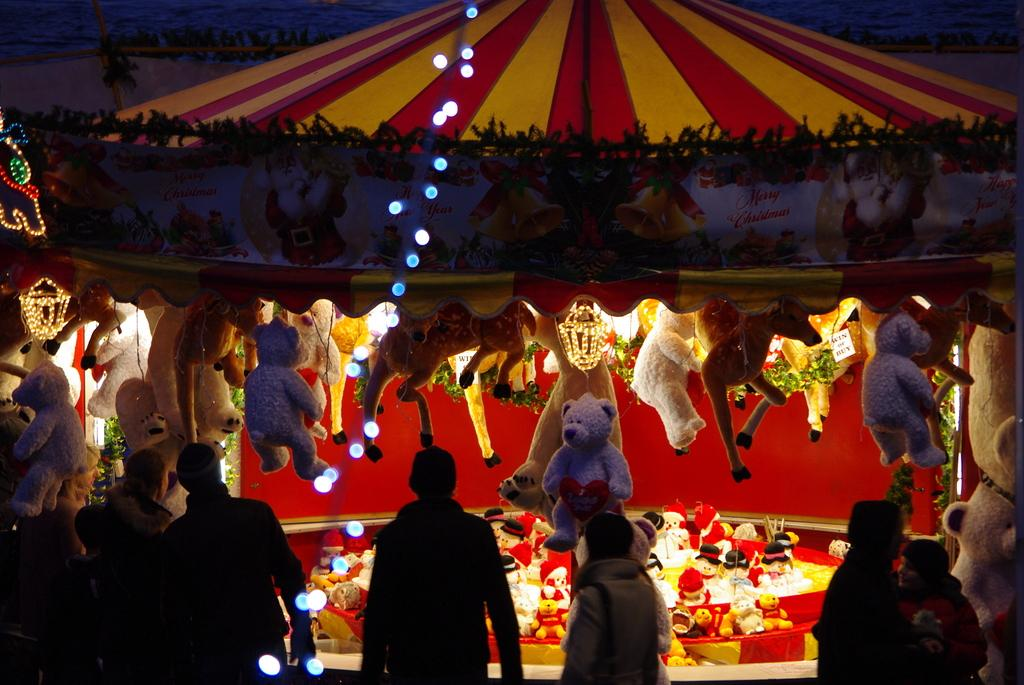Who or what can be seen in the image? There are people and dolls in the image. What structure is present in the image? There is a tent in the image. What can be used for illumination in the image? There are lights in the image. What can be seen hanging in the image? There is a banner in the image. What additional items are present in the image? There are decorative items in the image. What type of chess pieces are attacking the tent in the image? There are no chess pieces or attack depicted in the image; it features people, dolls, a tent, lights, a banner, and decorative items. 